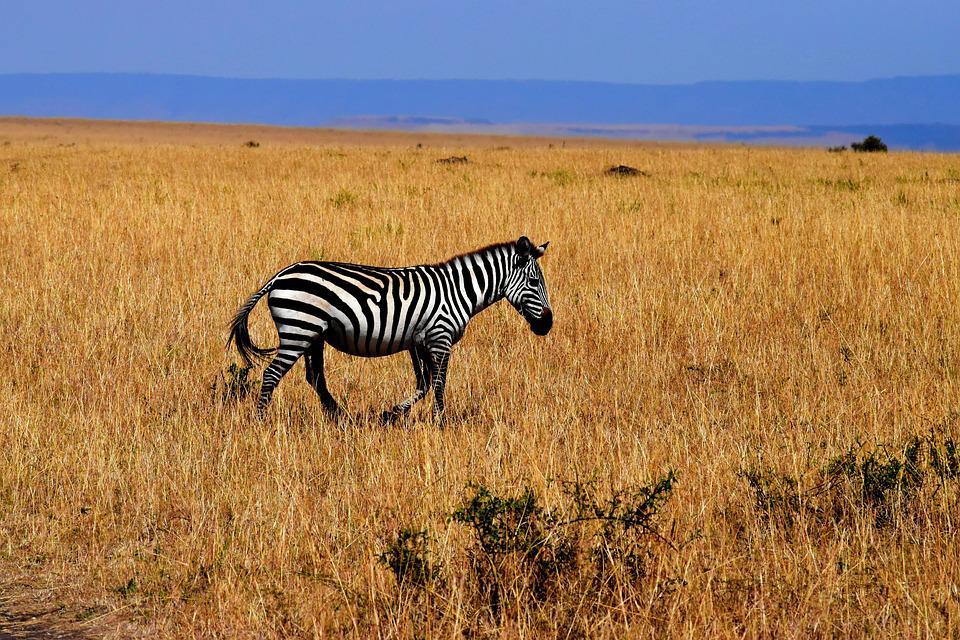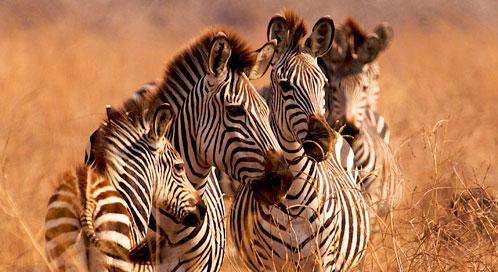The first image is the image on the left, the second image is the image on the right. For the images displayed, is the sentence "The right image contains no more than two zebras." factually correct? Answer yes or no. No. The first image is the image on the left, the second image is the image on the right. Given the left and right images, does the statement "One image shows a single zebra standing in profile with its head not bent to graze, and the other image shows a close cluster of zebras facing forward and backward." hold true? Answer yes or no. Yes. 